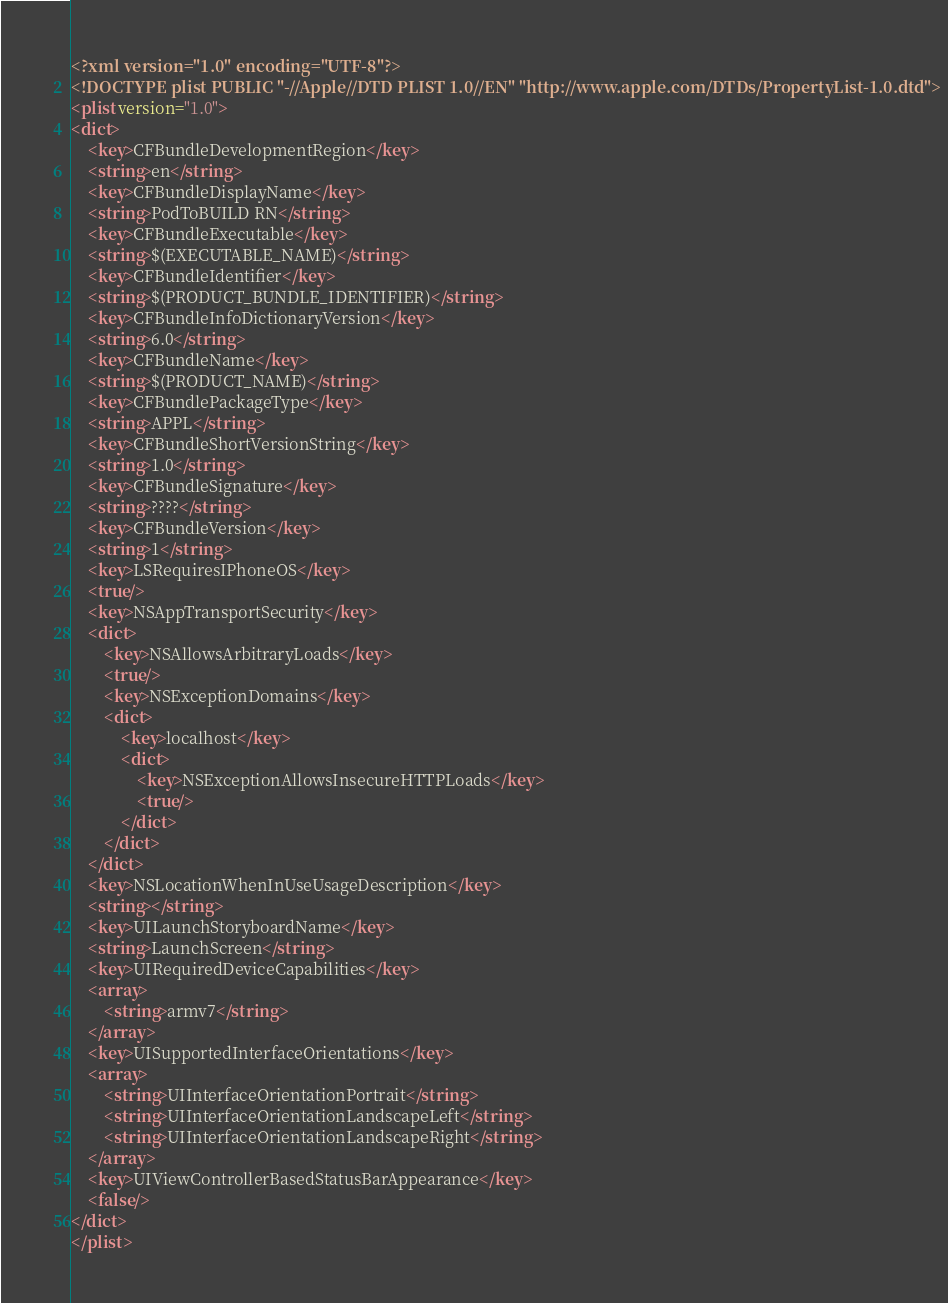Convert code to text. <code><loc_0><loc_0><loc_500><loc_500><_XML_><?xml version="1.0" encoding="UTF-8"?>
<!DOCTYPE plist PUBLIC "-//Apple//DTD PLIST 1.0//EN" "http://www.apple.com/DTDs/PropertyList-1.0.dtd">
<plist version="1.0">
<dict>
	<key>CFBundleDevelopmentRegion</key>
	<string>en</string>
	<key>CFBundleDisplayName</key>
	<string>PodToBUILD RN</string>
	<key>CFBundleExecutable</key>
	<string>$(EXECUTABLE_NAME)</string>
	<key>CFBundleIdentifier</key>
	<string>$(PRODUCT_BUNDLE_IDENTIFIER)</string>
	<key>CFBundleInfoDictionaryVersion</key>
	<string>6.0</string>
	<key>CFBundleName</key>
	<string>$(PRODUCT_NAME)</string>
	<key>CFBundlePackageType</key>
	<string>APPL</string>
	<key>CFBundleShortVersionString</key>
	<string>1.0</string>
	<key>CFBundleSignature</key>
	<string>????</string>
	<key>CFBundleVersion</key>
	<string>1</string>
	<key>LSRequiresIPhoneOS</key>
	<true/>
	<key>NSAppTransportSecurity</key>
	<dict>
		<key>NSAllowsArbitraryLoads</key>
		<true/>
		<key>NSExceptionDomains</key>
		<dict>
			<key>localhost</key>
			<dict>
				<key>NSExceptionAllowsInsecureHTTPLoads</key>
				<true/>
			</dict>
		</dict>
	</dict>
	<key>NSLocationWhenInUseUsageDescription</key>
	<string></string>
	<key>UILaunchStoryboardName</key>
	<string>LaunchScreen</string>
	<key>UIRequiredDeviceCapabilities</key>
	<array>
		<string>armv7</string>
	</array>
	<key>UISupportedInterfaceOrientations</key>
	<array>
		<string>UIInterfaceOrientationPortrait</string>
		<string>UIInterfaceOrientationLandscapeLeft</string>
		<string>UIInterfaceOrientationLandscapeRight</string>
	</array>
	<key>UIViewControllerBasedStatusBarAppearance</key>
	<false/>
</dict>
</plist>
</code> 